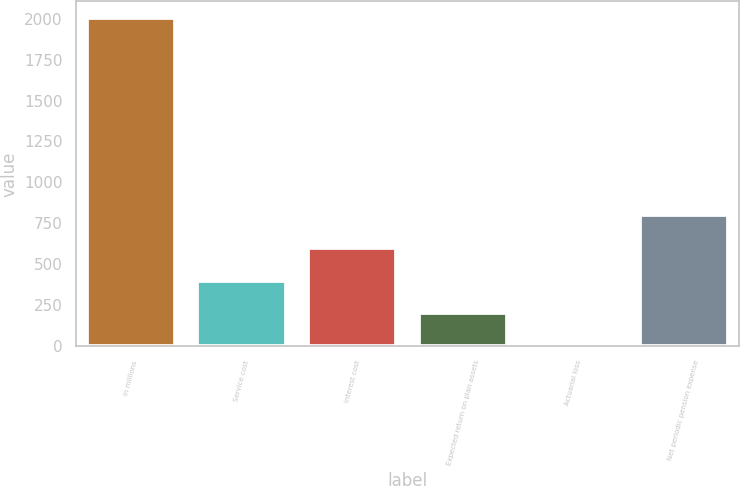<chart> <loc_0><loc_0><loc_500><loc_500><bar_chart><fcel>In millions<fcel>Service cost<fcel>Interest cost<fcel>Expected return on plan assets<fcel>Actuarial loss<fcel>Net periodic pension expense<nl><fcel>2004<fcel>401.6<fcel>601.9<fcel>201.3<fcel>1<fcel>802.2<nl></chart> 